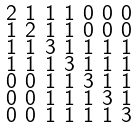Convert formula to latex. <formula><loc_0><loc_0><loc_500><loc_500>\begin{smallmatrix} 2 & 1 & 1 & 1 & 0 & 0 & 0 \\ 1 & 2 & 1 & 1 & 0 & 0 & 0 \\ 1 & 1 & 3 & 1 & 1 & 1 & 1 \\ 1 & 1 & 1 & 3 & 1 & 1 & 1 \\ 0 & 0 & 1 & 1 & 3 & 1 & 1 \\ 0 & 0 & 1 & 1 & 1 & 3 & 1 \\ 0 & 0 & 1 & 1 & 1 & 1 & 3 \end{smallmatrix}</formula> 